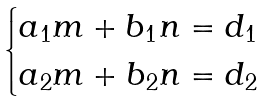Convert formula to latex. <formula><loc_0><loc_0><loc_500><loc_500>\begin{cases} a _ { 1 } m + b _ { 1 } n = d _ { 1 } \\ a _ { 2 } m + b _ { 2 } n = d _ { 2 } \end{cases}</formula> 